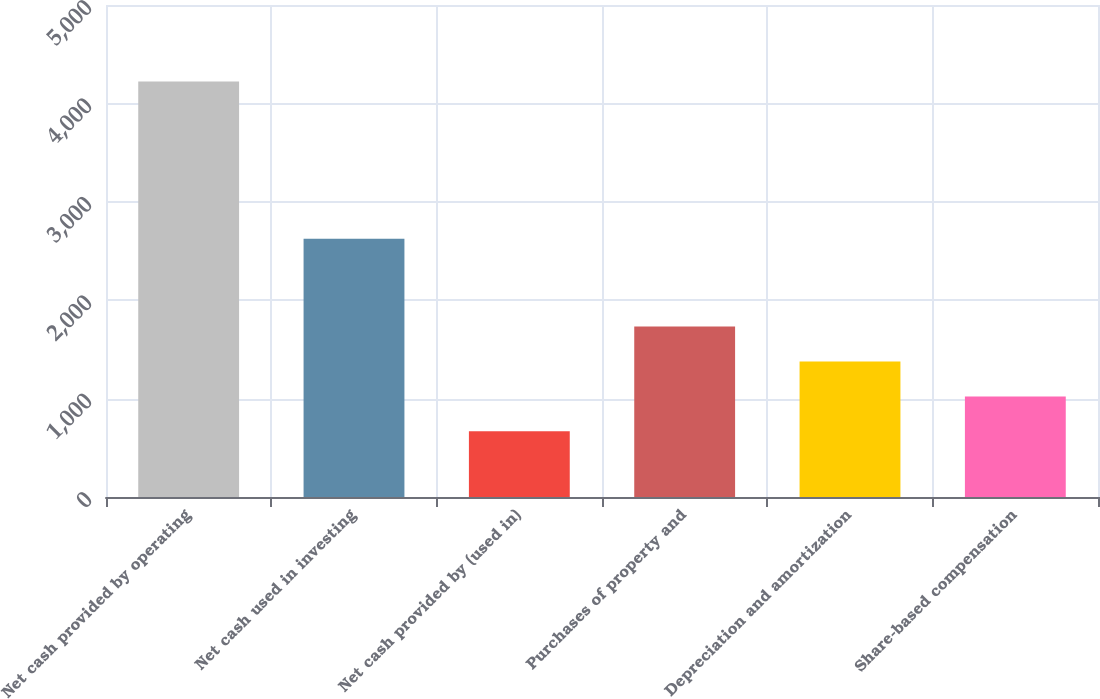<chart> <loc_0><loc_0><loc_500><loc_500><bar_chart><fcel>Net cash provided by operating<fcel>Net cash used in investing<fcel>Net cash provided by (used in)<fcel>Purchases of property and<fcel>Depreciation and amortization<fcel>Share-based compensation<nl><fcel>4222<fcel>2624<fcel>667<fcel>1733.5<fcel>1378<fcel>1022.5<nl></chart> 